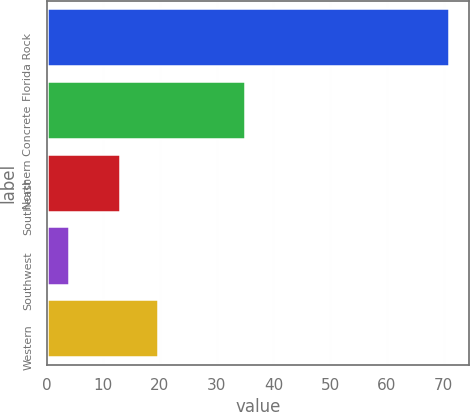<chart> <loc_0><loc_0><loc_500><loc_500><bar_chart><fcel>Florida Rock<fcel>Northern Concrete<fcel>Southeast<fcel>Southwest<fcel>Western<nl><fcel>71<fcel>35<fcel>13<fcel>4<fcel>19.7<nl></chart> 